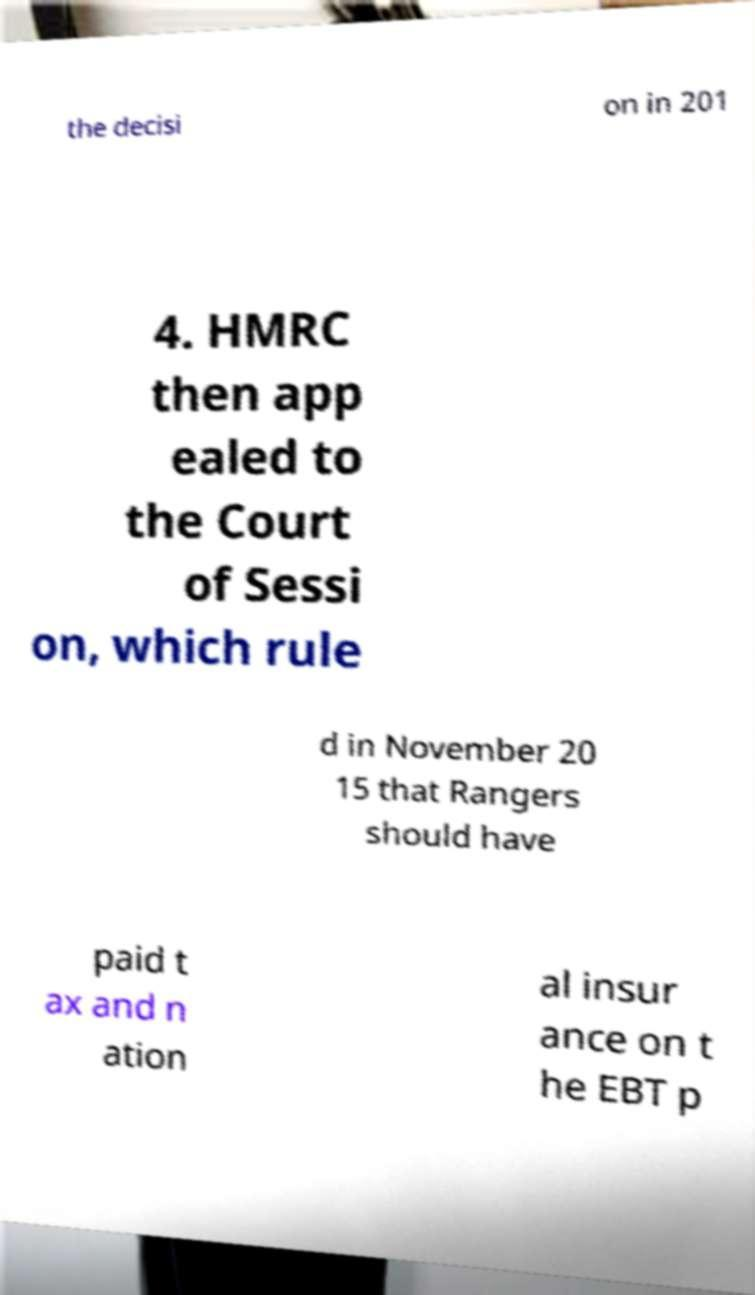What messages or text are displayed in this image? I need them in a readable, typed format. the decisi on in 201 4. HMRC then app ealed to the Court of Sessi on, which rule d in November 20 15 that Rangers should have paid t ax and n ation al insur ance on t he EBT p 